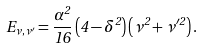<formula> <loc_0><loc_0><loc_500><loc_500>E _ { \nu , \nu ^ { \prime } } = \frac { \alpha ^ { 2 } } { 1 6 } \left ( 4 - \delta ^ { 2 } \right ) \left ( \nu ^ { 2 } + \nu ^ { \prime 2 } \right ) .</formula> 